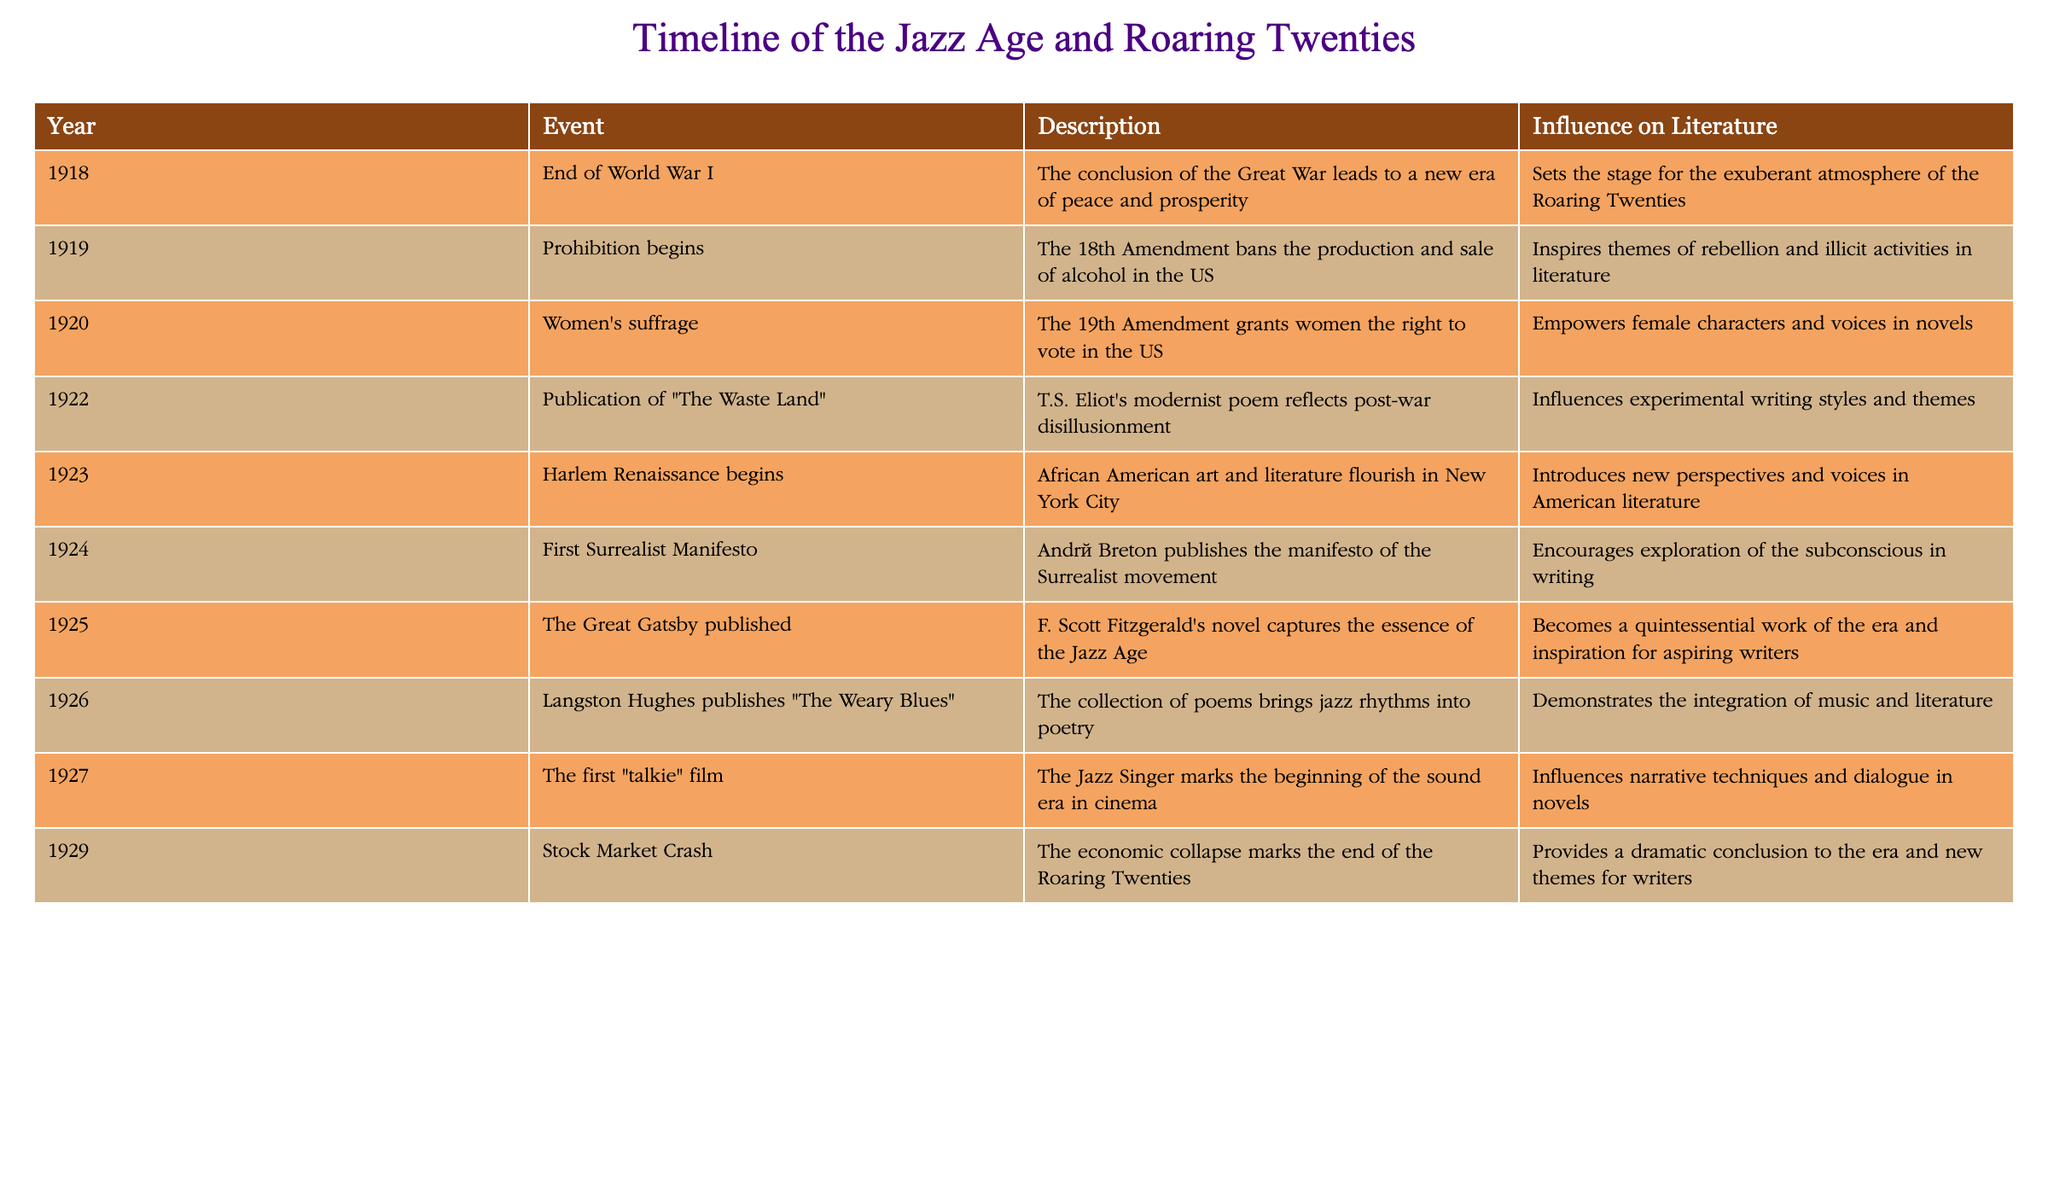What event marked the start of Prohibition? According to the table, Prohibition began in 1919 with the passage of the 18th Amendment, which banned the production and sale of alcohol in the United States.
Answer: 1919 Which literary work is attributed to T.S. Eliot and reflects post-war disillusionment? The table indicates that the publication of "The Waste Land" in 1922 is attributed to T.S. Eliot and reflects post-war disillusionment in its themes.
Answer: "The Waste Land" What influence did the Harlem Renaissance have on American literature? The table describes the Harlem Renaissance, which began in 1923, as an event that introduced new African American perspectives and voices into American literature, significantly influencing its development during this era.
Answer: New perspectives and voices How many events related to literature occurred between 1920 and 1927? From the table, we can see that there are four relevant events related to literature between 1920 and 1927: Women's suffrage (1920), publication of "The Waste Land" (1922), Harlem Renaissance begins (1923), and Langston Hughes publishes "The Weary Blues" (1926). Thus, the total is 4.
Answer: 4 Did the Stock Market Crash happen before or after the Harlem Renaissance? The table specifies that the Harlem Renaissance began in 1923 and the Stock Market Crash occurred in 1929, indicating that the crash happened after the Harlem Renaissance began.
Answer: After Which event had the most direct impact on the rights of women in America? The table states that Women's suffrage, granted by the 19th Amendment in 1920, directly impacted the rights of women by allowing them to vote, signifying a crucial step in the women's rights movement in the United States.
Answer: Women's suffrage What is the significance of "The Great Gatsby" regarding the Jazz Age? The table shows that "The Great Gatsby," published in 1925 by F. Scott Fitzgerald, captures the essence of the Jazz Age and is considered a quintessential work of this era, serving as inspiration for many writers.
Answer: Quintessential work of the era How did Prohibition influence literary themes during the Roaring Twenties? The table notes that Prohibition, beginning in 1919, inspired themes of rebellion and illicit activities in literature, which became prevalent during the Roaring Twenties as authors explored the complexities of social norms and laws.
Answer: Themes of rebellion and illicit activities What was the relationship between the end of World War I and the Jazz Age? The table clarifies that the end of World War I in 1918 led to a new era of peace and prosperity, setting the stage for the exuberant atmosphere that characterized the Roaring Twenties, thereby influencing cultural and literary developments during that time.
Answer: New era of peace and prosperity 